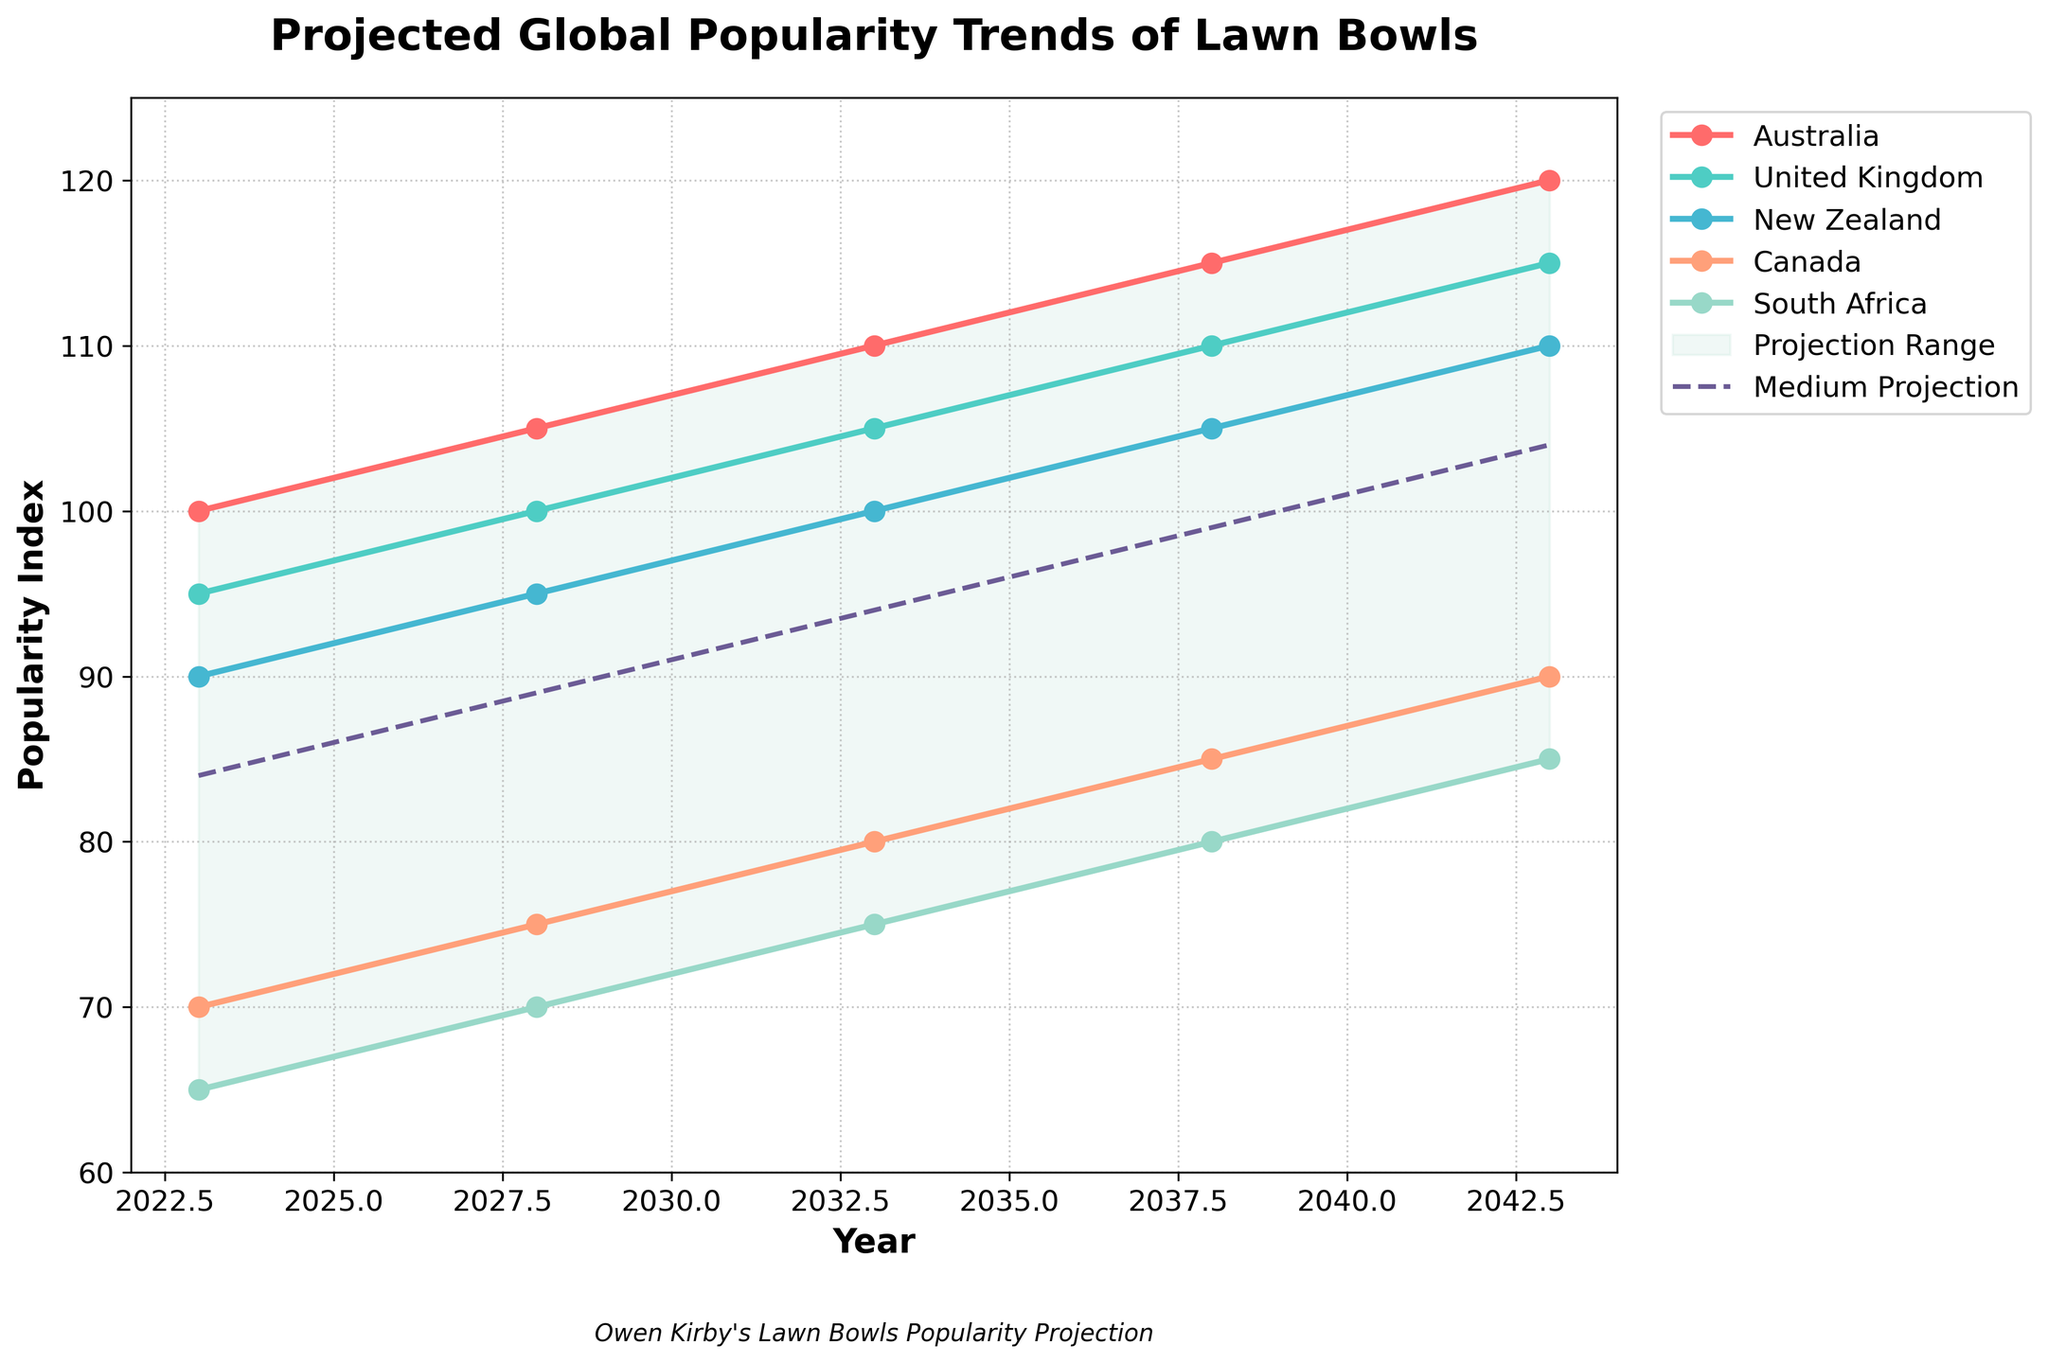What is the title of the plot? The title of the plot is usually located at the top center of the figure. In this case, it indicates what the overall figure is representing.
Answer: Projected Global Popularity Trends of Lawn Bowls How many countries' popularity trends are shown in the plot? To determine this, look at the legend or the different colored lines on the plot corresponding to different countries.
Answer: 5 Which country has the highest projected popularity index in 2023? By looking at the values for each country in the year 2023, the one with the highest index can be identified.
Answer: Australia What is the medium projection value for the year 2043? Look at the dashed line representing the medium projection and note its value at the year 2043.
Answer: 104 How does the popularity index of New Zealand in 2028 compare to Canada in the same year? Compare the values for New Zealand and Canada in the year 2028, which are shown on the Y axis for that particular year.
Answer: New Zealand has a higher index than Canada What is the range of the projected popularity index for the year 2033? Look at the boundary values (Low and High) for the year 2033. Subtract the Low value from the High value to find the range.
Answer: 35 Between which years does the popularity index of South Africa increase the most? Examine the plot trend for South Africa and note the differences in values between consecutive years. Identify the pair of years with the largest increase.
Answer: 2023 - 2028 What is the average projected popularity index for Australia across all years? Sum the values of Australia's index for each year and divide by the number of years (5). (100 + 105 + 110 + 115 + 120) / 5 = 110
Answer: 110 Which country shows a consistent increase in popularity index each year? Observe each country's trend line and see which has no drops throughout the years.
Answer: All shown countries have consistent increases 